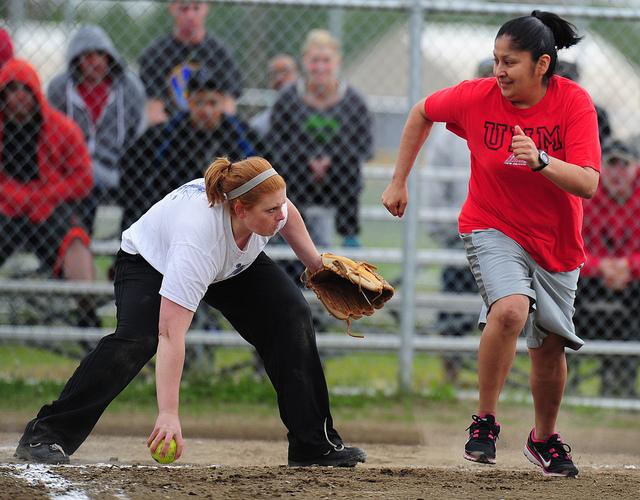Are these people professional athletes?
Keep it brief. No. What sport is this?
Short answer required. Softball. What is the woman on the left wearing around her head?
Answer briefly. Headband. What color is shirt the woman on the right wearing?
Short answer required. Red. Are they wearing baseball hats?
Short answer required. No. What color hair does the woman walking have?
Answer briefly. Black. 